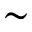<formula> <loc_0><loc_0><loc_500><loc_500>\sim</formula> 